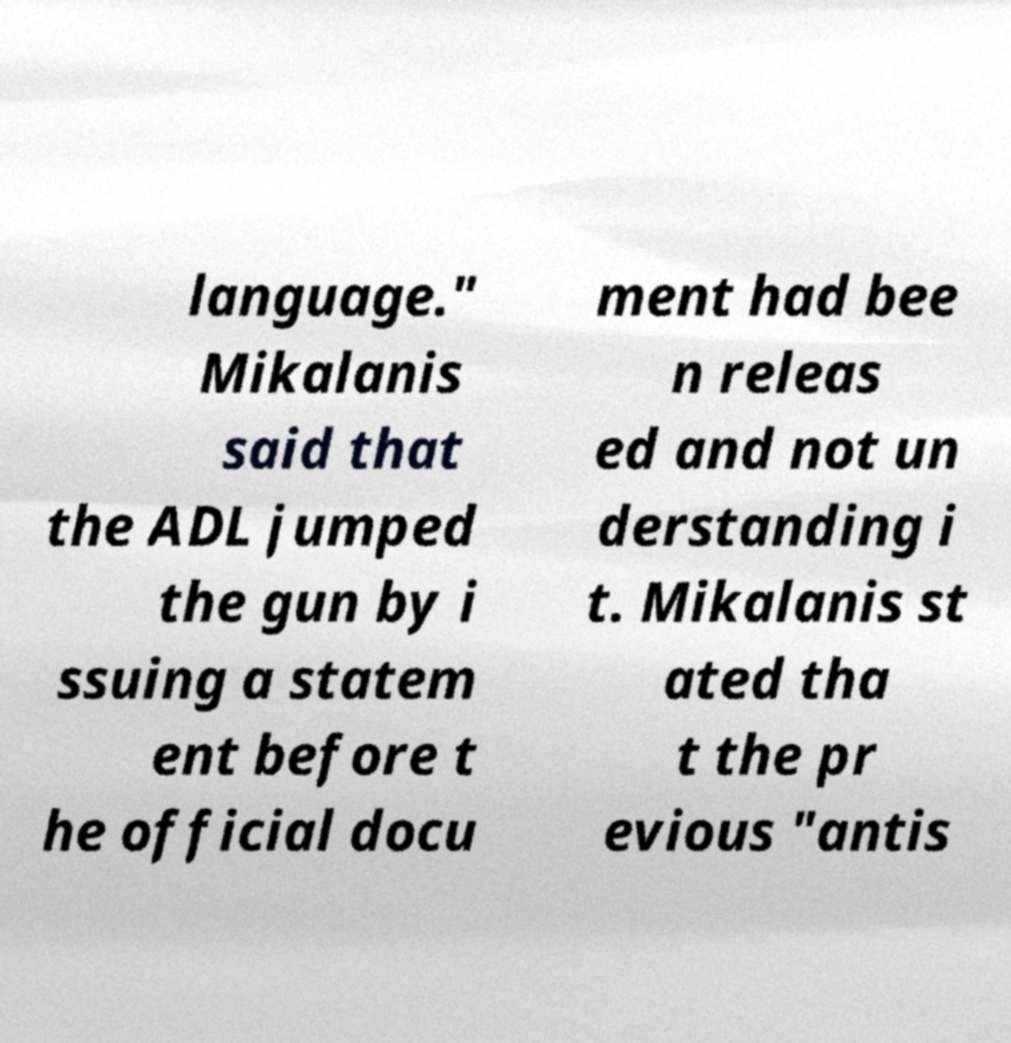What messages or text are displayed in this image? I need them in a readable, typed format. language." Mikalanis said that the ADL jumped the gun by i ssuing a statem ent before t he official docu ment had bee n releas ed and not un derstanding i t. Mikalanis st ated tha t the pr evious "antis 